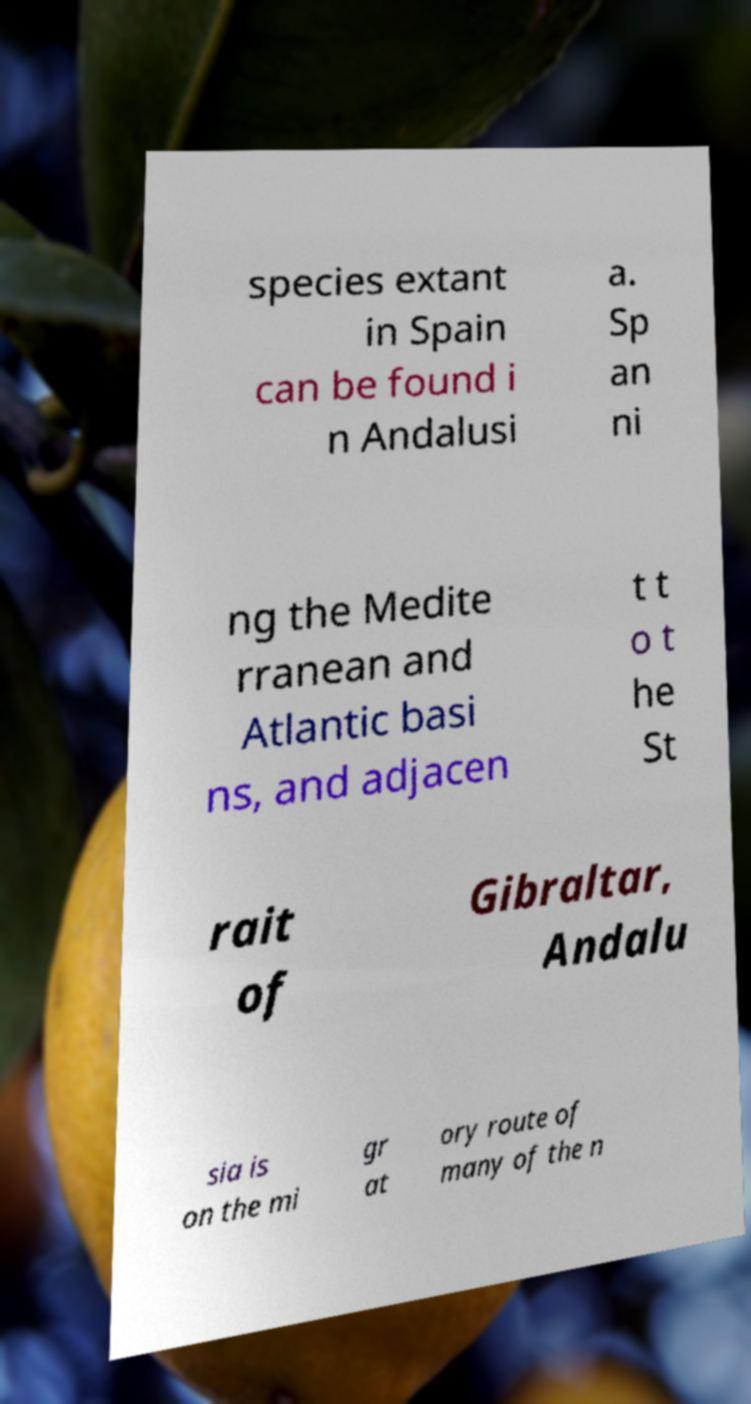Can you accurately transcribe the text from the provided image for me? species extant in Spain can be found i n Andalusi a. Sp an ni ng the Medite rranean and Atlantic basi ns, and adjacen t t o t he St rait of Gibraltar, Andalu sia is on the mi gr at ory route of many of the n 